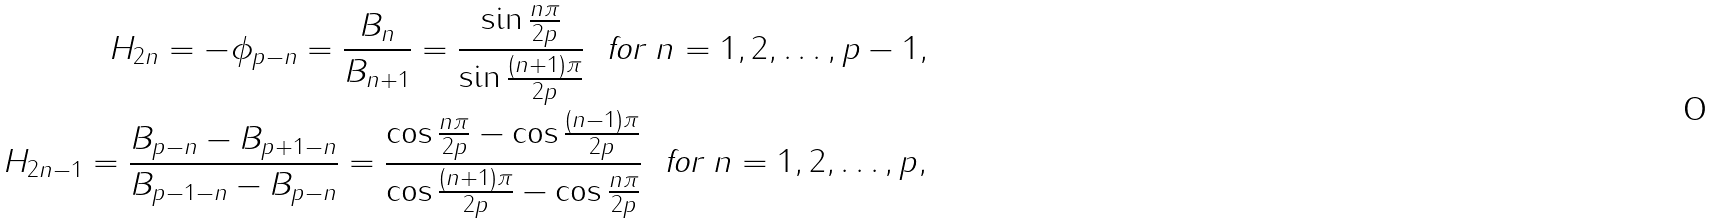Convert formula to latex. <formula><loc_0><loc_0><loc_500><loc_500>H _ { 2 n } = - \phi _ { p - n } = \frac { B _ { n } } { B _ { n + 1 } } = \frac { \sin \frac { n \pi } { 2 p } } { \sin \frac { ( n + 1 ) \pi } { 2 p } } \ \text { for } n = 1 , 2 , \dots , p - 1 , \\ H _ { 2 n - 1 } = \frac { B _ { p - n } - B _ { p + 1 - n } } { B _ { p - 1 - n } - B _ { p - n } } = \frac { \cos \frac { n \pi } { 2 p } - \cos \frac { ( n - 1 ) \pi } { 2 p } } { \cos \frac { ( n + 1 ) \pi } { 2 p } - \cos \frac { n \pi } { 2 p } } \ \text { for } n = 1 , 2 , \dots , p ,</formula> 